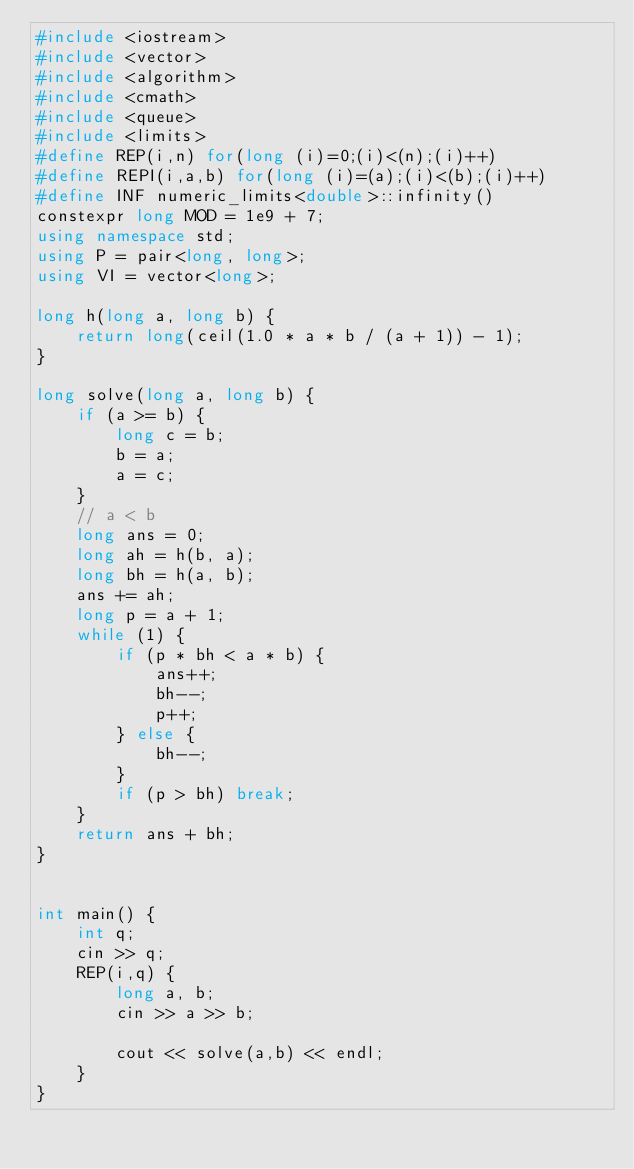<code> <loc_0><loc_0><loc_500><loc_500><_C++_>#include <iostream>
#include <vector>
#include <algorithm>
#include <cmath>
#include <queue>
#include <limits>
#define REP(i,n) for(long (i)=0;(i)<(n);(i)++)
#define REPI(i,a,b) for(long (i)=(a);(i)<(b);(i)++)
#define INF numeric_limits<double>::infinity()
constexpr long MOD = 1e9 + 7;
using namespace std;
using P = pair<long, long>;
using VI = vector<long>;

long h(long a, long b) {
    return long(ceil(1.0 * a * b / (a + 1)) - 1);
}

long solve(long a, long b) {
    if (a >= b) {
        long c = b;
        b = a;
        a = c;
    }
    // a < b
    long ans = 0;
    long ah = h(b, a);
    long bh = h(a, b);
    ans += ah;
    long p = a + 1;
    while (1) {
        if (p * bh < a * b) {
            ans++;
            bh--;
            p++;
        } else {
            bh--;
        }
        if (p > bh) break;
    }
    return ans + bh;
}


int main() {
    int q;
    cin >> q;
    REP(i,q) {
        long a, b;
        cin >> a >> b;

        cout << solve(a,b) << endl;
    }
}
</code> 